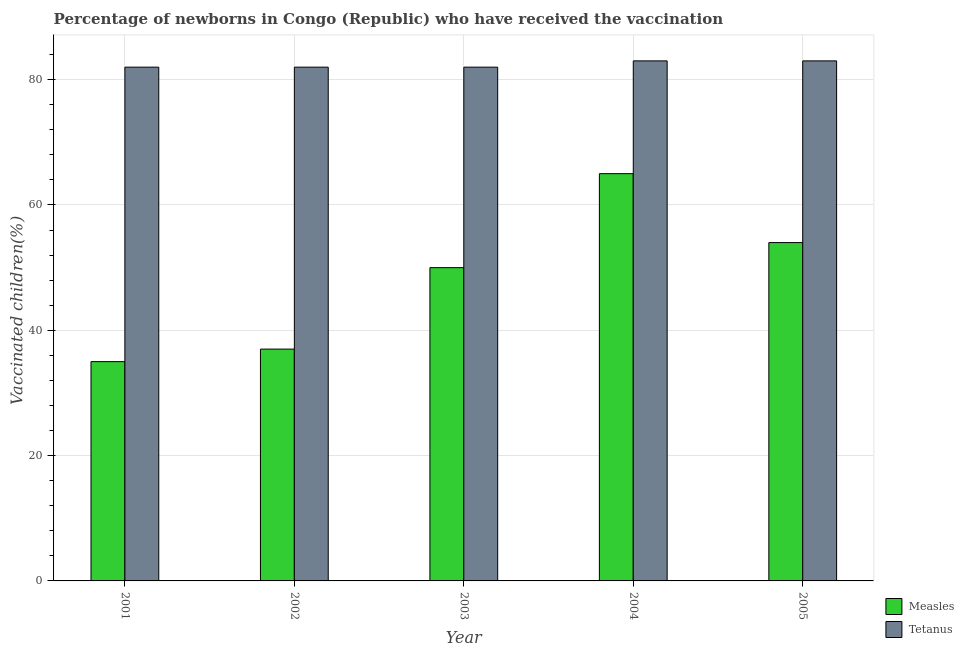Are the number of bars on each tick of the X-axis equal?
Your response must be concise. Yes. What is the percentage of newborns who received vaccination for tetanus in 2001?
Your response must be concise. 82. Across all years, what is the maximum percentage of newborns who received vaccination for tetanus?
Offer a very short reply. 83. Across all years, what is the minimum percentage of newborns who received vaccination for tetanus?
Give a very brief answer. 82. In which year was the percentage of newborns who received vaccination for measles minimum?
Ensure brevity in your answer.  2001. What is the total percentage of newborns who received vaccination for tetanus in the graph?
Make the answer very short. 412. What is the difference between the percentage of newborns who received vaccination for tetanus in 2003 and that in 2004?
Give a very brief answer. -1. What is the difference between the percentage of newborns who received vaccination for measles in 2005 and the percentage of newborns who received vaccination for tetanus in 2003?
Give a very brief answer. 4. What is the average percentage of newborns who received vaccination for measles per year?
Your answer should be very brief. 48.2. In how many years, is the percentage of newborns who received vaccination for measles greater than 24 %?
Your answer should be compact. 5. Is the percentage of newborns who received vaccination for tetanus in 2001 less than that in 2005?
Ensure brevity in your answer.  Yes. Is the difference between the percentage of newborns who received vaccination for tetanus in 2001 and 2005 greater than the difference between the percentage of newborns who received vaccination for measles in 2001 and 2005?
Your response must be concise. No. What is the difference between the highest and the second highest percentage of newborns who received vaccination for tetanus?
Provide a succinct answer. 0. What is the difference between the highest and the lowest percentage of newborns who received vaccination for measles?
Your response must be concise. 30. Is the sum of the percentage of newborns who received vaccination for measles in 2001 and 2003 greater than the maximum percentage of newborns who received vaccination for tetanus across all years?
Offer a terse response. Yes. What does the 2nd bar from the left in 2002 represents?
Provide a short and direct response. Tetanus. What does the 2nd bar from the right in 2001 represents?
Provide a short and direct response. Measles. How many bars are there?
Your answer should be very brief. 10. How many years are there in the graph?
Your answer should be very brief. 5. What is the difference between two consecutive major ticks on the Y-axis?
Ensure brevity in your answer.  20. Does the graph contain any zero values?
Make the answer very short. No. What is the title of the graph?
Your response must be concise. Percentage of newborns in Congo (Republic) who have received the vaccination. What is the label or title of the Y-axis?
Your answer should be compact. Vaccinated children(%)
. What is the Vaccinated children(%)
 of Measles in 2001?
Provide a succinct answer. 35. What is the Vaccinated children(%)
 in Tetanus in 2002?
Offer a very short reply. 82. What is the Vaccinated children(%)
 in Tetanus in 2003?
Keep it short and to the point. 82. What is the Vaccinated children(%)
 of Measles in 2004?
Give a very brief answer. 65. What is the Vaccinated children(%)
 in Measles in 2005?
Your answer should be compact. 54. What is the Vaccinated children(%)
 in Tetanus in 2005?
Make the answer very short. 83. Across all years, what is the minimum Vaccinated children(%)
 in Measles?
Give a very brief answer. 35. What is the total Vaccinated children(%)
 of Measles in the graph?
Your answer should be compact. 241. What is the total Vaccinated children(%)
 in Tetanus in the graph?
Your response must be concise. 412. What is the difference between the Vaccinated children(%)
 in Measles in 2001 and that in 2002?
Offer a very short reply. -2. What is the difference between the Vaccinated children(%)
 of Measles in 2001 and that in 2004?
Your response must be concise. -30. What is the difference between the Vaccinated children(%)
 of Tetanus in 2001 and that in 2005?
Make the answer very short. -1. What is the difference between the Vaccinated children(%)
 in Measles in 2002 and that in 2003?
Your answer should be compact. -13. What is the difference between the Vaccinated children(%)
 in Tetanus in 2002 and that in 2005?
Keep it short and to the point. -1. What is the difference between the Vaccinated children(%)
 of Tetanus in 2004 and that in 2005?
Provide a short and direct response. 0. What is the difference between the Vaccinated children(%)
 of Measles in 2001 and the Vaccinated children(%)
 of Tetanus in 2002?
Offer a terse response. -47. What is the difference between the Vaccinated children(%)
 of Measles in 2001 and the Vaccinated children(%)
 of Tetanus in 2003?
Offer a terse response. -47. What is the difference between the Vaccinated children(%)
 of Measles in 2001 and the Vaccinated children(%)
 of Tetanus in 2004?
Your response must be concise. -48. What is the difference between the Vaccinated children(%)
 of Measles in 2001 and the Vaccinated children(%)
 of Tetanus in 2005?
Your response must be concise. -48. What is the difference between the Vaccinated children(%)
 in Measles in 2002 and the Vaccinated children(%)
 in Tetanus in 2003?
Ensure brevity in your answer.  -45. What is the difference between the Vaccinated children(%)
 in Measles in 2002 and the Vaccinated children(%)
 in Tetanus in 2004?
Make the answer very short. -46. What is the difference between the Vaccinated children(%)
 in Measles in 2002 and the Vaccinated children(%)
 in Tetanus in 2005?
Ensure brevity in your answer.  -46. What is the difference between the Vaccinated children(%)
 of Measles in 2003 and the Vaccinated children(%)
 of Tetanus in 2004?
Your response must be concise. -33. What is the difference between the Vaccinated children(%)
 in Measles in 2003 and the Vaccinated children(%)
 in Tetanus in 2005?
Give a very brief answer. -33. What is the average Vaccinated children(%)
 of Measles per year?
Offer a very short reply. 48.2. What is the average Vaccinated children(%)
 in Tetanus per year?
Provide a short and direct response. 82.4. In the year 2001, what is the difference between the Vaccinated children(%)
 of Measles and Vaccinated children(%)
 of Tetanus?
Give a very brief answer. -47. In the year 2002, what is the difference between the Vaccinated children(%)
 of Measles and Vaccinated children(%)
 of Tetanus?
Provide a succinct answer. -45. In the year 2003, what is the difference between the Vaccinated children(%)
 of Measles and Vaccinated children(%)
 of Tetanus?
Give a very brief answer. -32. What is the ratio of the Vaccinated children(%)
 in Measles in 2001 to that in 2002?
Provide a succinct answer. 0.95. What is the ratio of the Vaccinated children(%)
 of Tetanus in 2001 to that in 2003?
Provide a short and direct response. 1. What is the ratio of the Vaccinated children(%)
 of Measles in 2001 to that in 2004?
Offer a terse response. 0.54. What is the ratio of the Vaccinated children(%)
 in Tetanus in 2001 to that in 2004?
Your answer should be very brief. 0.99. What is the ratio of the Vaccinated children(%)
 of Measles in 2001 to that in 2005?
Offer a very short reply. 0.65. What is the ratio of the Vaccinated children(%)
 in Measles in 2002 to that in 2003?
Ensure brevity in your answer.  0.74. What is the ratio of the Vaccinated children(%)
 in Measles in 2002 to that in 2004?
Your answer should be very brief. 0.57. What is the ratio of the Vaccinated children(%)
 in Measles in 2002 to that in 2005?
Provide a succinct answer. 0.69. What is the ratio of the Vaccinated children(%)
 in Tetanus in 2002 to that in 2005?
Ensure brevity in your answer.  0.99. What is the ratio of the Vaccinated children(%)
 in Measles in 2003 to that in 2004?
Provide a succinct answer. 0.77. What is the ratio of the Vaccinated children(%)
 of Measles in 2003 to that in 2005?
Ensure brevity in your answer.  0.93. What is the ratio of the Vaccinated children(%)
 in Measles in 2004 to that in 2005?
Provide a short and direct response. 1.2. What is the difference between the highest and the second highest Vaccinated children(%)
 of Tetanus?
Give a very brief answer. 0. What is the difference between the highest and the lowest Vaccinated children(%)
 in Measles?
Your response must be concise. 30. 